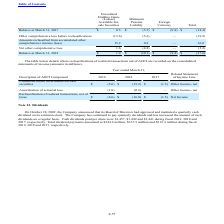From Microchip Technology's financial document, Which years does the table provide information for reclassifications of realized transactions out of AOCI are recorded on the consolidated statements of income? The document contains multiple relevant values: 2019, 2018, 2017. From the document: "Balance at March 31, 2017 $ 0.3 $ (5.3) $ (9.4) $ (14.4) Description of AOCI Component 2019 2018 2017 Balance at March 31, 2018 $ 1.9 $ (10.1) $ (9.4)..." Also, What were the Unrealized losses on available-for-sale securities in 2017? According to the financial document, (1.5) (in millions). The relevant text states: "n available-for-sale securities $ (5.6) $ (15.2) $ (1.5) Other income, net..." Also, What was the Amortization of actuarial loss in 2019? According to the financial document, (1.0) (in millions). The relevant text states: "Amortization of actuarial loss (1.0) (0.8) — Other income, net..." Also, can you calculate: What was the change in the Amortization of actuarial loss between 2018 and 2019? Based on the calculation: -1.0-(-0.8), the result is -0.2 (in millions). This is based on the information: "Amortization of actuarial loss (1.0) (0.8) — Other income, net Amortization of actuarial loss (1.0) (0.8) — Other income, net..." The key data points involved are: 0.8, 1.0. Also, can you calculate: What was the change in the Unrealized losses on available-for-sale securities between 2017 and 2018? Based on the calculation: -15.2-(-1.5), the result is -13.7 (in millions). This is based on the information: "rom accumulated other comprehensive income (loss) 15.2 0.8 — 16.0 available-for-sale securities $ (5.6) $ (15.2) $ (1.5) Other income, net..." The key data points involved are: 1.5, 15.2. Also, can you calculate: What was the percentage change in the Reclassification of realized transactions, net of taxes between 2018 and 2019? To answer this question, I need to perform calculations using the financial data. The calculation is: (-6.6-(-16.0))/-16.0, which equals -58.75 (percentage). This is based on the information: "ated other comprehensive income (loss) 15.2 0.8 — 16.0 ication of realized transactions, net of taxes $ (6.6) $ (16.0) $ (1.5) Net Income..." The key data points involved are: 16.0, 6.6. 